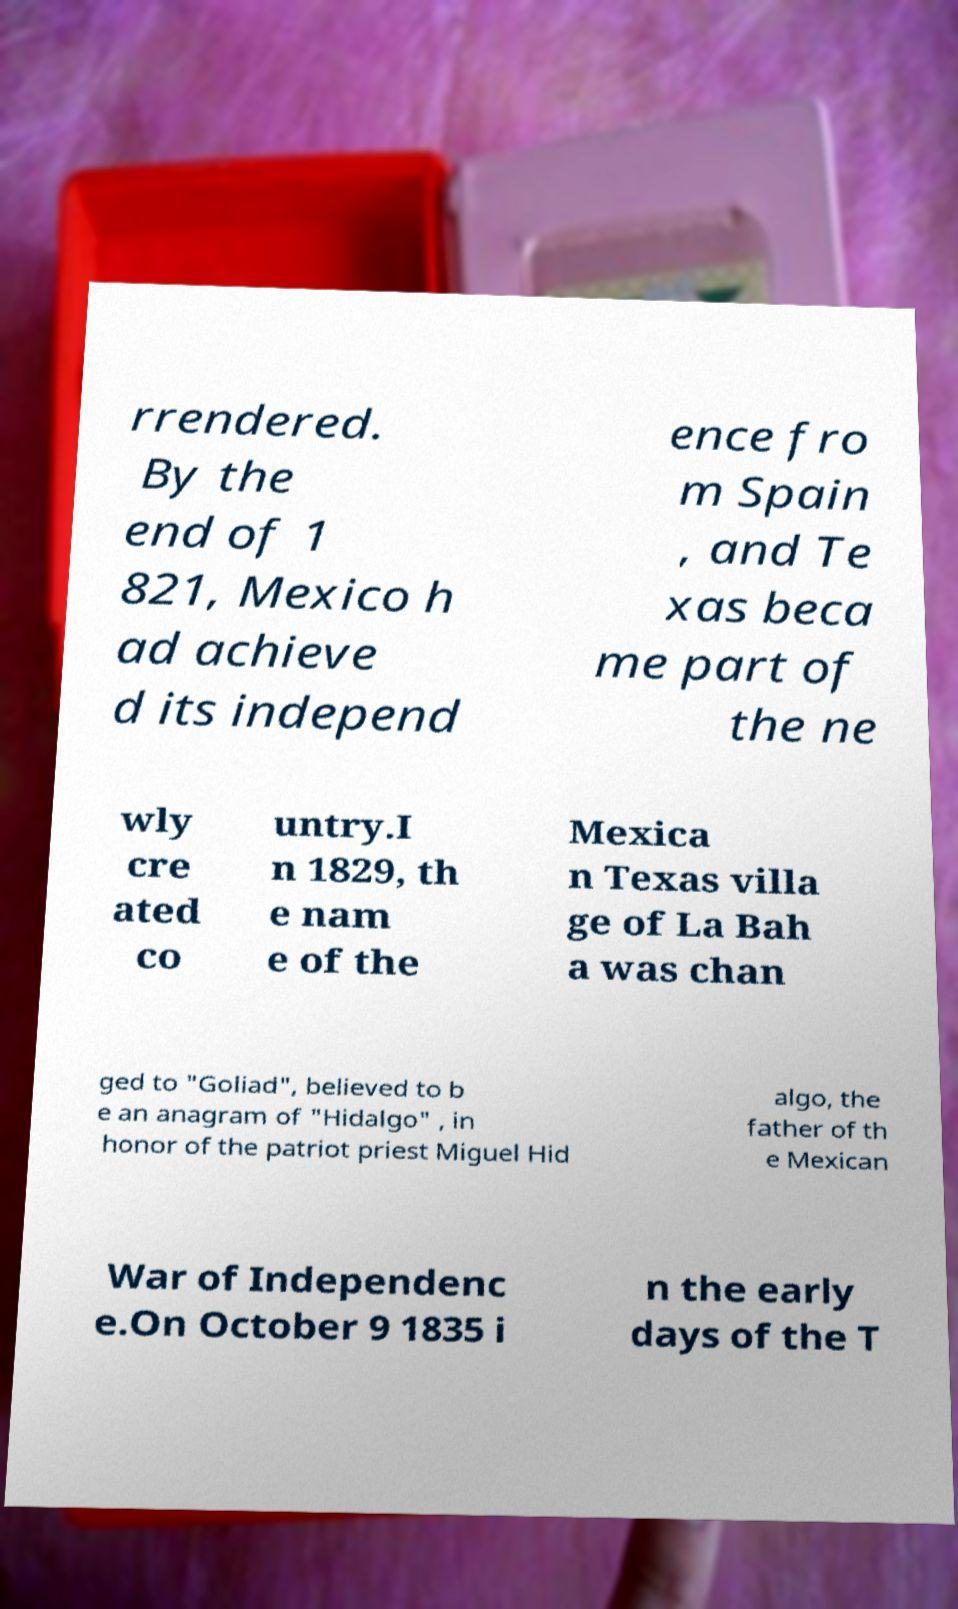Can you read and provide the text displayed in the image?This photo seems to have some interesting text. Can you extract and type it out for me? rrendered. By the end of 1 821, Mexico h ad achieve d its independ ence fro m Spain , and Te xas beca me part of the ne wly cre ated co untry.I n 1829, th e nam e of the Mexica n Texas villa ge of La Bah a was chan ged to "Goliad", believed to b e an anagram of "Hidalgo" , in honor of the patriot priest Miguel Hid algo, the father of th e Mexican War of Independenc e.On October 9 1835 i n the early days of the T 